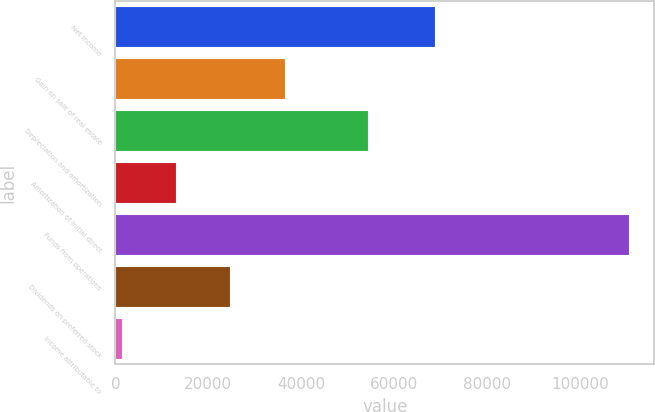Convert chart. <chart><loc_0><loc_0><loc_500><loc_500><bar_chart><fcel>Net income<fcel>Gain on sale of real estate<fcel>Depreciation and amortization<fcel>Amortization of initial direct<fcel>Funds from operations<fcel>Dividends on preferred stock<fcel>Income attributable to<nl><fcel>68756<fcel>36393.4<fcel>54350<fcel>13053.8<fcel>110432<fcel>24723.6<fcel>1384<nl></chart> 